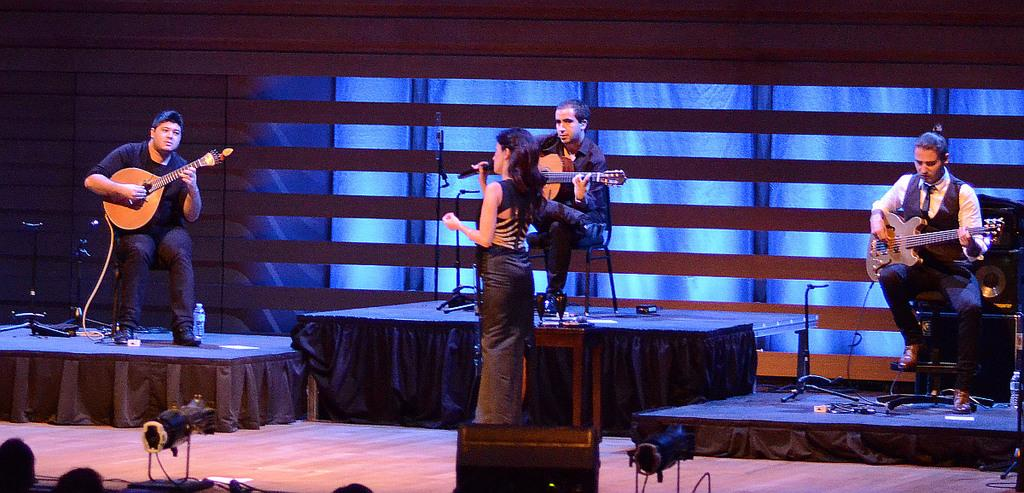What is the main activity of the group of persons in the image? The group of persons in the image are playing the guitar. What is the position of the group of persons in the image? The group of persons are sitting. Can you describe the woman in the image? The woman in the image is standing and holding a microphone in her hand. What type of feather can be seen on the yak in the image? There is no yak or feather present in the image. 